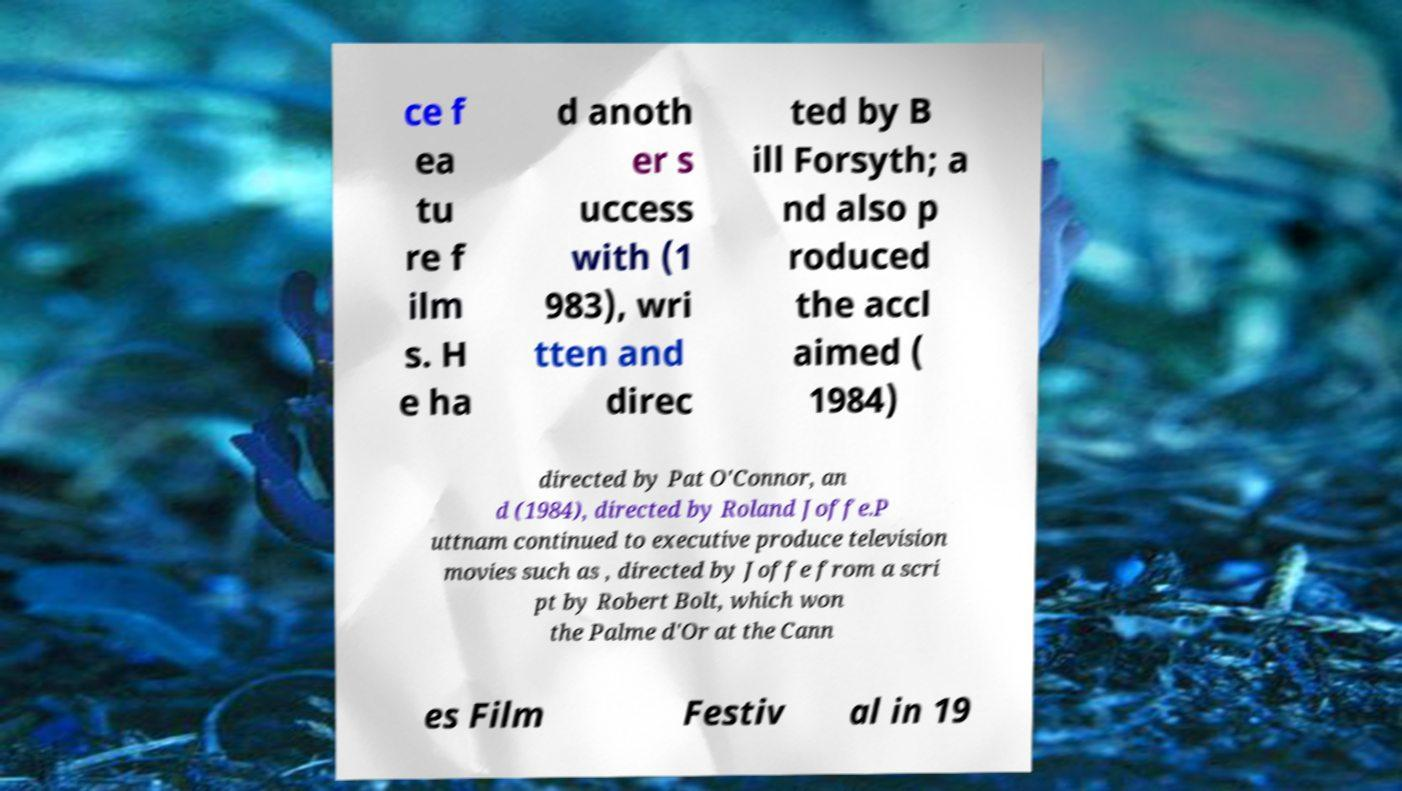Could you assist in decoding the text presented in this image and type it out clearly? ce f ea tu re f ilm s. H e ha d anoth er s uccess with (1 983), wri tten and direc ted by B ill Forsyth; a nd also p roduced the accl aimed ( 1984) directed by Pat O'Connor, an d (1984), directed by Roland Joffe.P uttnam continued to executive produce television movies such as , directed by Joffe from a scri pt by Robert Bolt, which won the Palme d'Or at the Cann es Film Festiv al in 19 